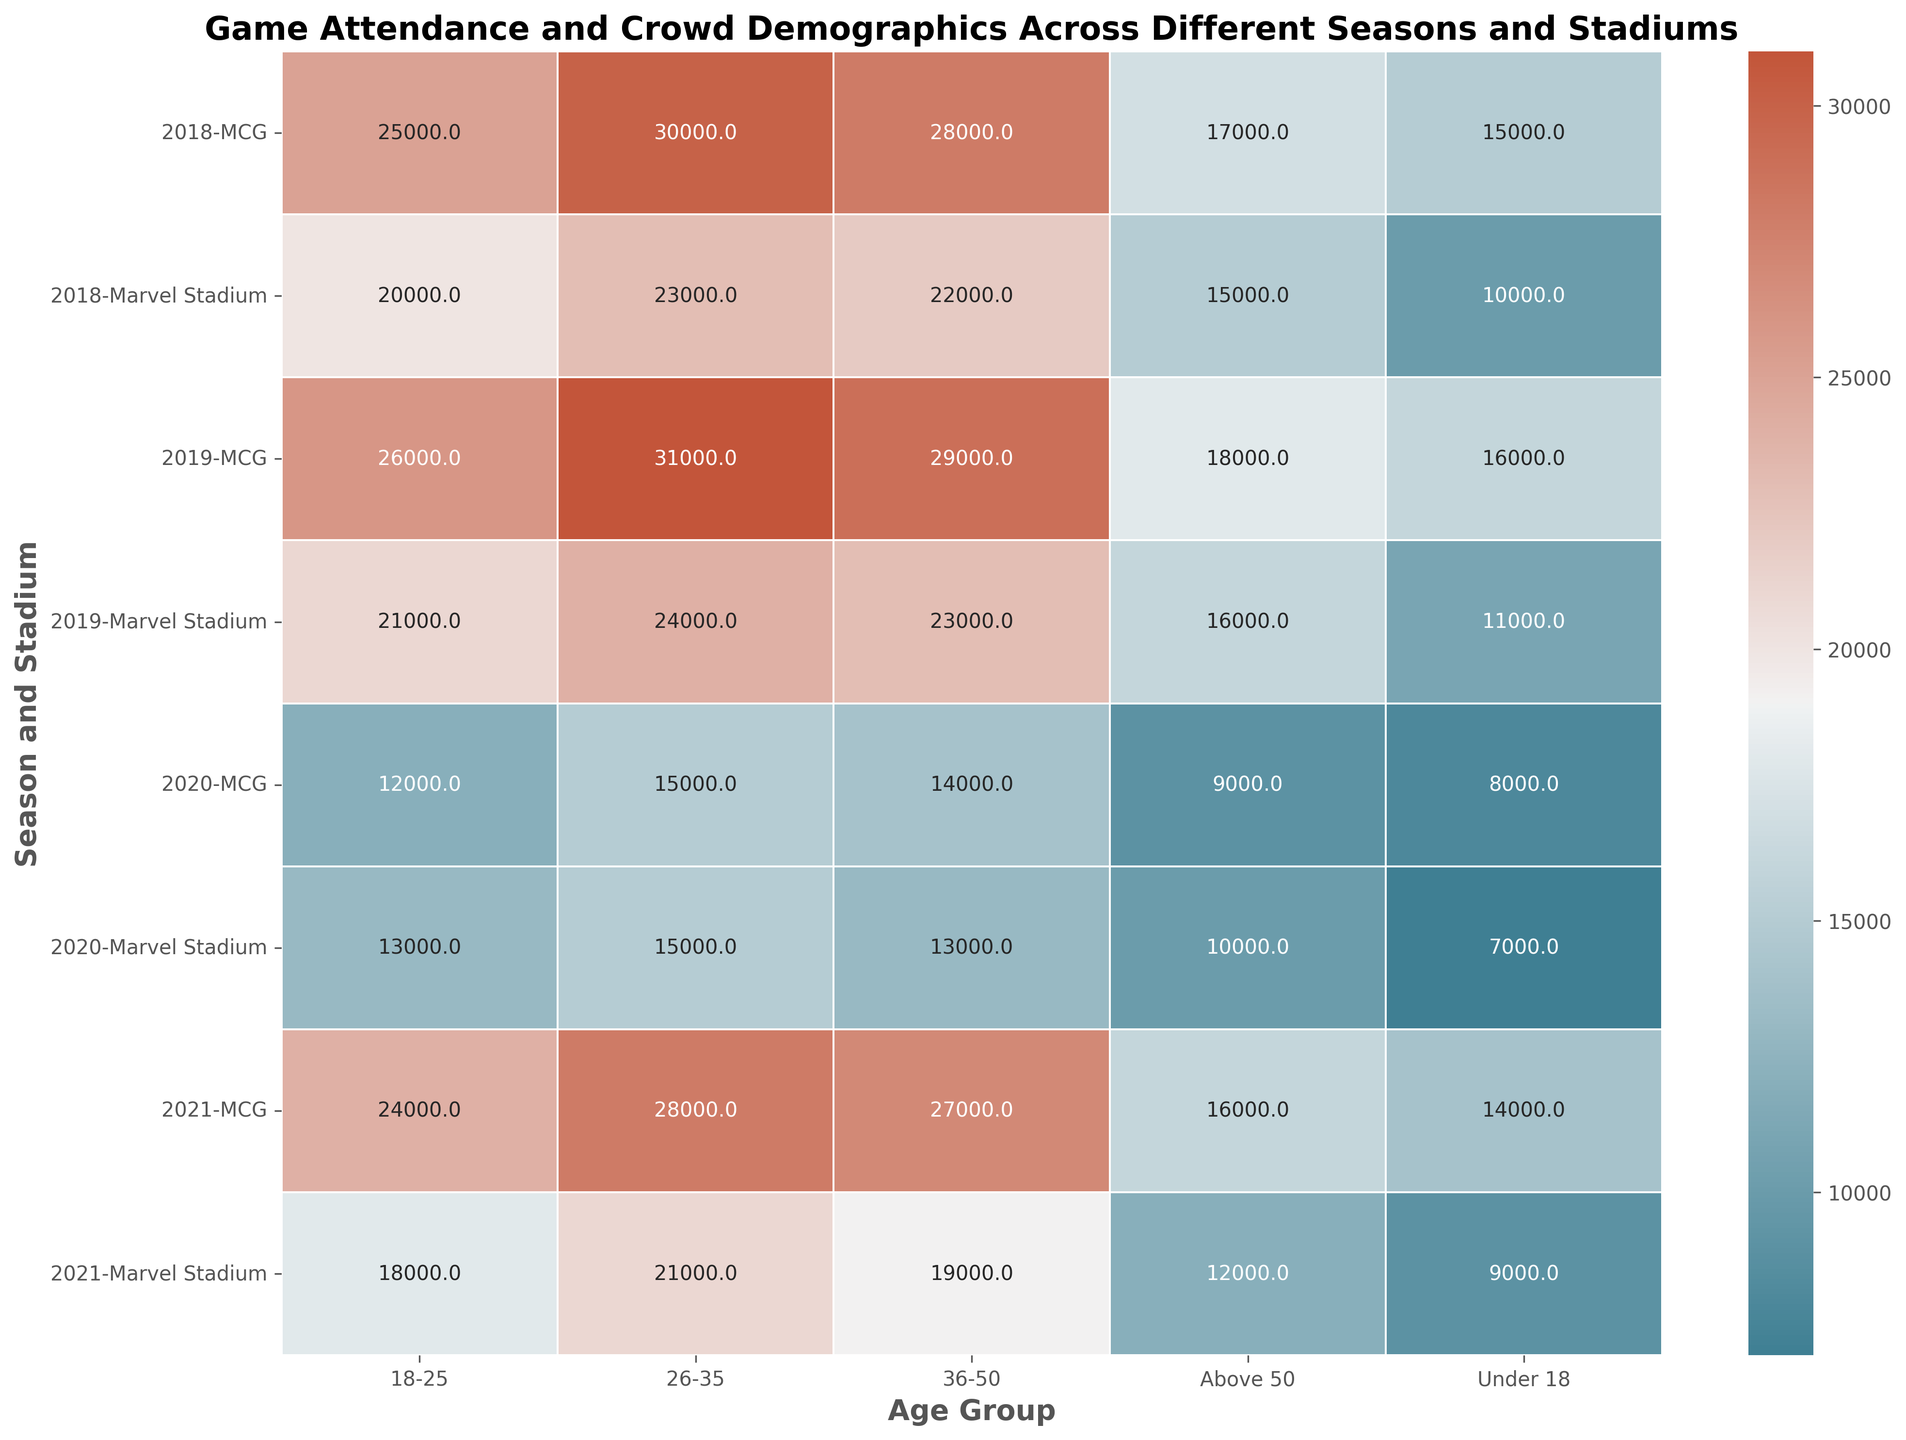How did the average attendance for the 'Under 18' age group at MCG change from 2018 to 2020? To find the change in average attendance for the 'Under 18' age group at MCG from 2018 to 2020, identify the attendance values for those years and calculate the difference: 15000 in 2018 and 8000 in 2020. Therefore, the change is 15000 - 8000 = 7000.
Answer: Decreased by 7000 Which age group had the highest average attendance at Marvel Stadium in 2019? Check the attendance values for all age groups at Marvel Stadium in 2019: 'Under 18' (11000), '18-25' (21000), '26-35' (24000), '36-50' (23000), and 'Above 50' (16000). The '26-35' age group has the highest value (24000).
Answer: '26-35' By how much did the average attendance for the '18-25' age group change at MCG from 2020 to 2021? First, identify the average attendance for the '18-25' age group at MCG in 2020 and 2021, which are 12000 and 24000 respectively. Then, calculate the difference: 24000 - 12000 = 12000.
Answer: Increased by 12000 When was the lowest average attendance observed for the 'Above 50' age group, and at which stadium? Review the average attendance for the 'Above 50' age group across all seasons and stadiums. The lowest value is 9000 at MCG in 2020.
Answer: 2020, MCG Which stadium experienced a greater decrease in average attendance for the '36-50' age group from 2019 to 2020? Calculate the decrease for each stadium. For MCG, it was 29000 in 2019 to 14000 in 2020, a decrease of 15000. For Marvel Stadium, it was 23000 in 2019 to 13000 in 2020, a decrease of 10000. Compare the decreases to find MCG had a greater decrease.
Answer: MCG What's the overall average attendance across all age groups at Marvel Stadium in 2021? Sum the average attendance values for all age groups at Marvel Stadium in 2021: 9000 + 18000 + 21000 + 19000 + 12000 = 79000. Divide by the number of age groups (5) to get the overall average: 79000 / 5 = 15800.
Answer: 15800 How does the average attendance for the '26-35' age group at MCG in 2021 compare to that in 2019? The average attendance for the '26-35' age group at MCG in 2021 is 28000 and in 2019 is 31000. To compare, subtract the 2021 value from the 2019 value: 31000 - 28000 = 3000.
Answer: Decreased by 3000 Which season saw the highest overall average attendance across all age groups and stadiums? Calculate the total attendance for each season across all age groups and stadiums, then find the average. Compare these overall averages to determine the highest one. For example, total for 2018: (15000+25000+30000+28000+17000) + (10000+20000+23000+22000+15000) = 285000. Do the same for other years and identify the highest overall average.
Answer: 2019 